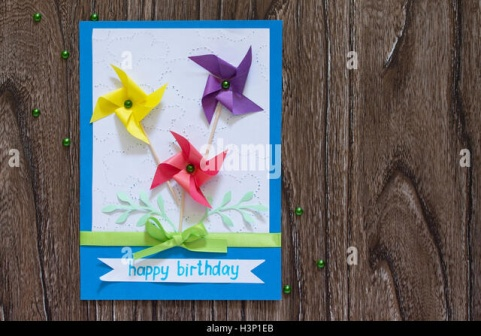If you were to create a story based on this birthday card, how would it begin? In a quaint little town, nestled among the rolling hills and lush green fields, there was a special tradition. Every year, on the eve of a child's birthday, the townsfolk would gather to create the most exquisite birthday cards. This year, it was Lily's turn. As she carefully picked out the blue card with three colorful pinwheels, she couldn't wait to see the smile on her best friend Emma's face. Little did she know, this birthday card held a secret wish-making power, one that would make Emma's birthday an unforgettable adventure. What kind of adventure did the birthday card lead Emma on? Emma's adventure began the moment she blew on the pinwheels, making her birthday wish. Suddenly, she found herself transported to a magical land where pinwheels were the key to unlocking enchanted doors. Each door led to a different realm: one filled with candy, another with talking animals, and yet another with music that made everyone dance. Emma's journey through these realms not only fulfilled her wildest dreams but also taught her the value of friendship, courage, and kindness. 